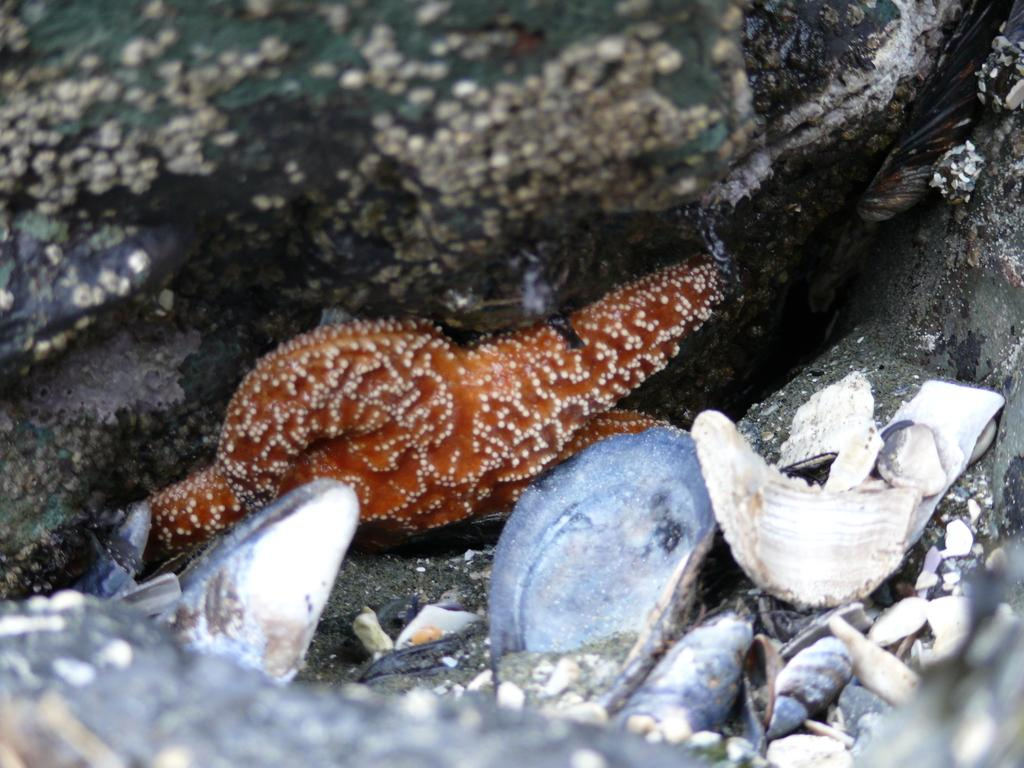What type of sea creature is in the image? There is a starfish in the image. What other objects can be seen in the image? There are shells in the image. What type of sponge is used to support the starfish's theory in the image? There is no sponge or theory present in the image; it only features a starfish and shells. 